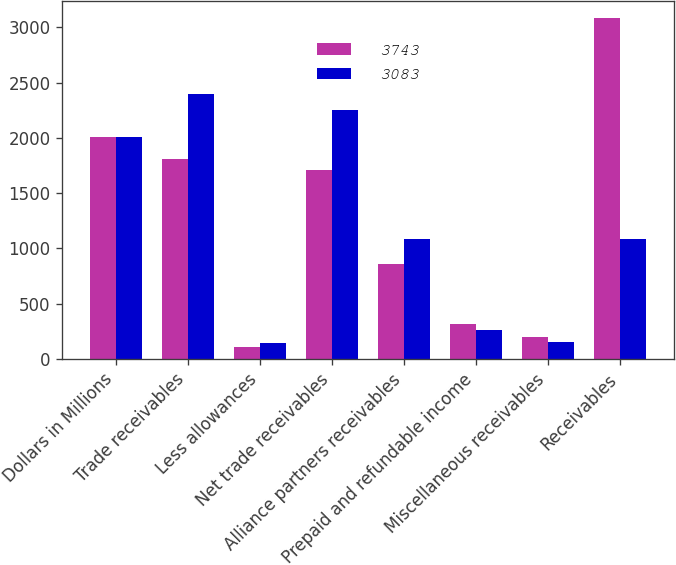Convert chart to OTSL. <chart><loc_0><loc_0><loc_500><loc_500><stacked_bar_chart><ecel><fcel>Dollars in Millions<fcel>Trade receivables<fcel>Less allowances<fcel>Net trade receivables<fcel>Alliance partners receivables<fcel>Prepaid and refundable income<fcel>Miscellaneous receivables<fcel>Receivables<nl><fcel>3743<fcel>2012<fcel>1812<fcel>104<fcel>1708<fcel>857<fcel>319<fcel>199<fcel>3083<nl><fcel>3083<fcel>2011<fcel>2397<fcel>147<fcel>2250<fcel>1081<fcel>256<fcel>156<fcel>1081<nl></chart> 